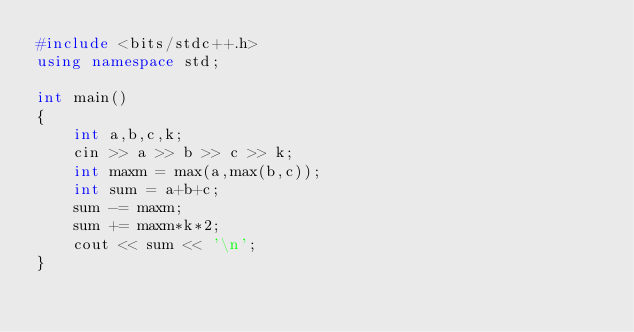Convert code to text. <code><loc_0><loc_0><loc_500><loc_500><_C++_>#include <bits/stdc++.h>
using namespace std;

int main()
{
	int a,b,c,k;
	cin >> a >> b >> c >> k;
	int maxm = max(a,max(b,c));
	int sum = a+b+c;
	sum -= maxm;
	sum += maxm*k*2;
	cout << sum << '\n';
}</code> 